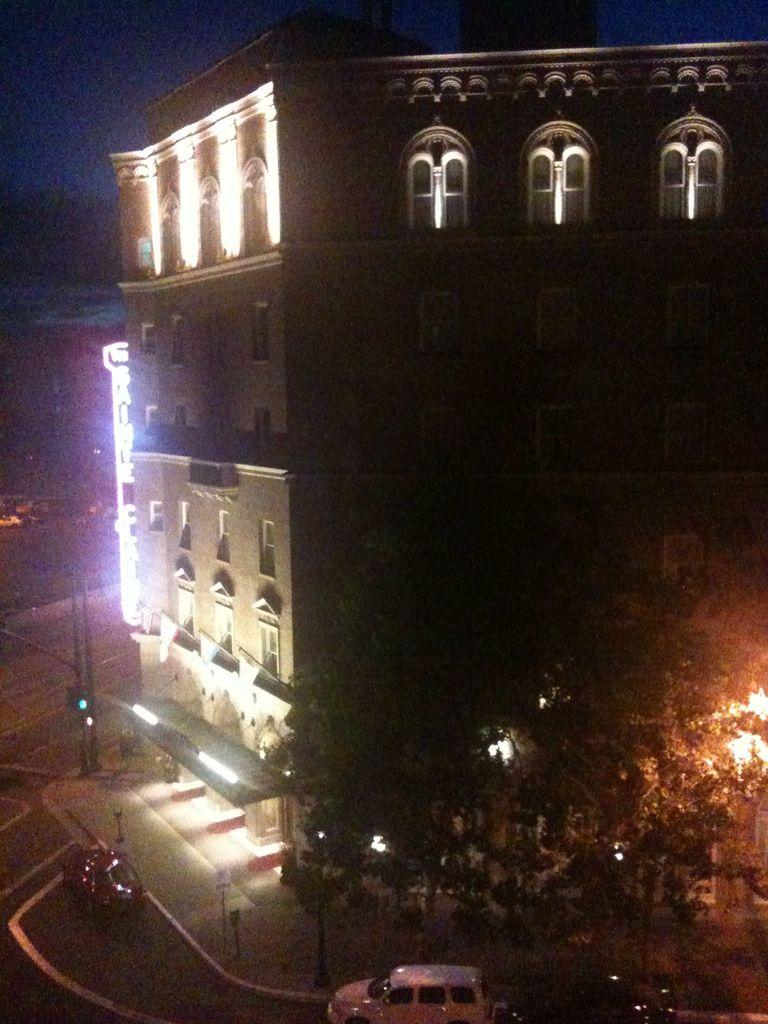What is the main structure in the middle of the image? There is a house in the middle of the image. What type of vegetation is on the right side of the image? There are trees on the right side of the image. What is happening at the bottom of the image? Vehicles are moving on a road at the bottom of the image. Can you see any cabbage growing in the image? There is no cabbage present in the image. What type of feather is visible on the house in the image? There are no feathers visible on the house in the image. 